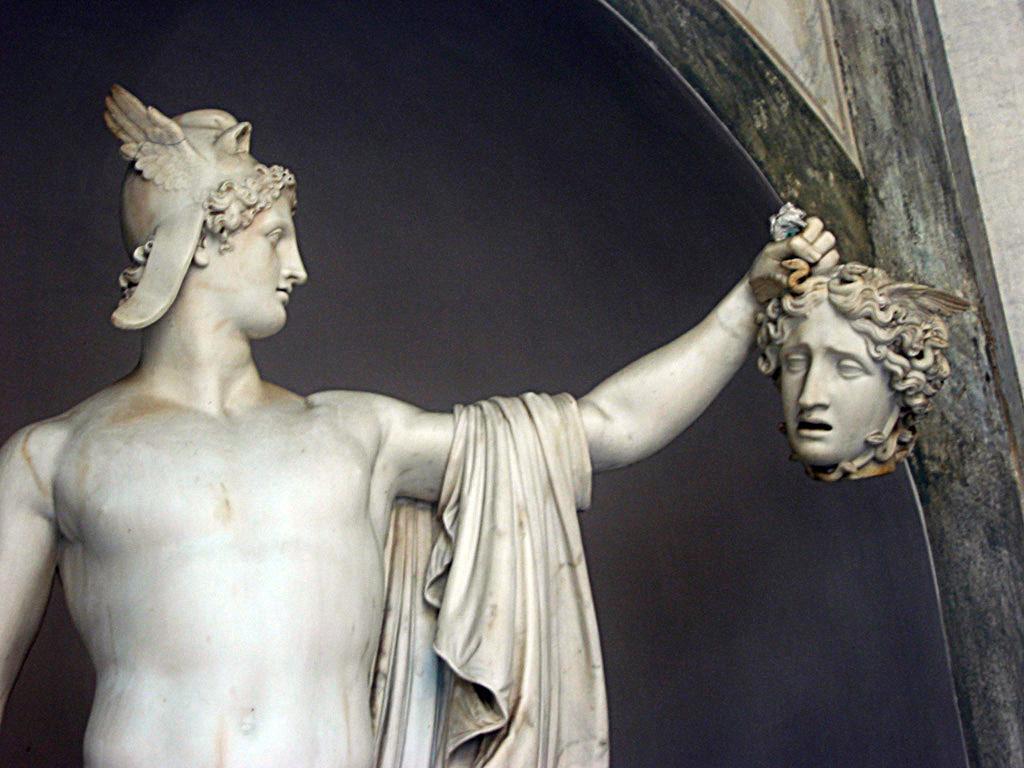Can you describe this image briefly? In the picture we can see a sculpture of a man holding a head of a woman, the sculpture is white in color and beside to it, we can see a wall which is a black shade on it. 